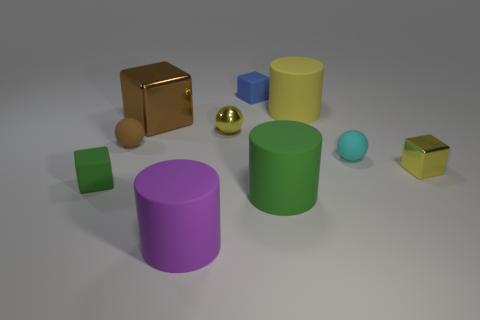Subtract all cyan blocks. Subtract all cyan cylinders. How many blocks are left? 4 Subtract all balls. How many objects are left? 7 Subtract all yellow balls. Subtract all small yellow blocks. How many objects are left? 8 Add 2 small cyan rubber spheres. How many small cyan rubber spheres are left? 3 Add 3 small rubber cylinders. How many small rubber cylinders exist? 3 Subtract 0 red balls. How many objects are left? 10 